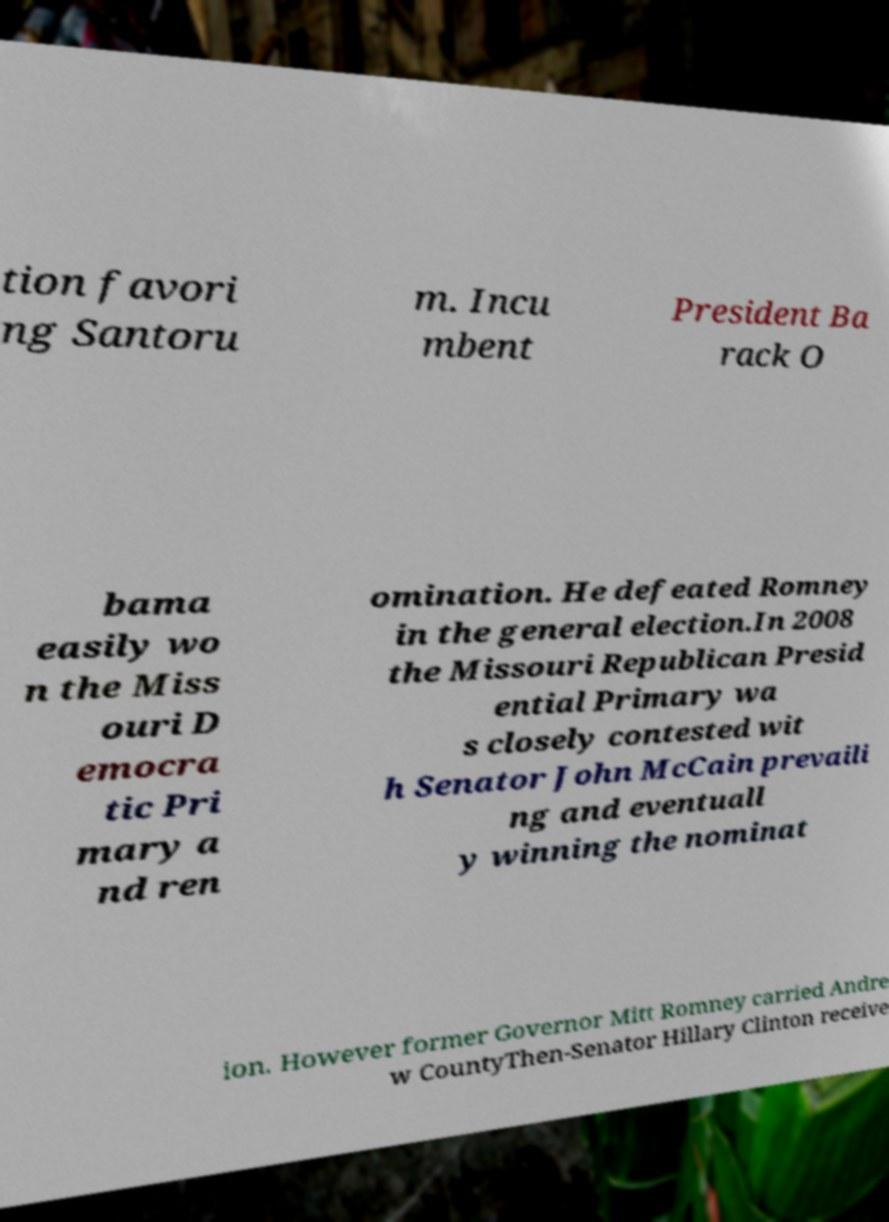I need the written content from this picture converted into text. Can you do that? tion favori ng Santoru m. Incu mbent President Ba rack O bama easily wo n the Miss ouri D emocra tic Pri mary a nd ren omination. He defeated Romney in the general election.In 2008 the Missouri Republican Presid ential Primary wa s closely contested wit h Senator John McCain prevaili ng and eventuall y winning the nominat ion. However former Governor Mitt Romney carried Andre w CountyThen-Senator Hillary Clinton receive 